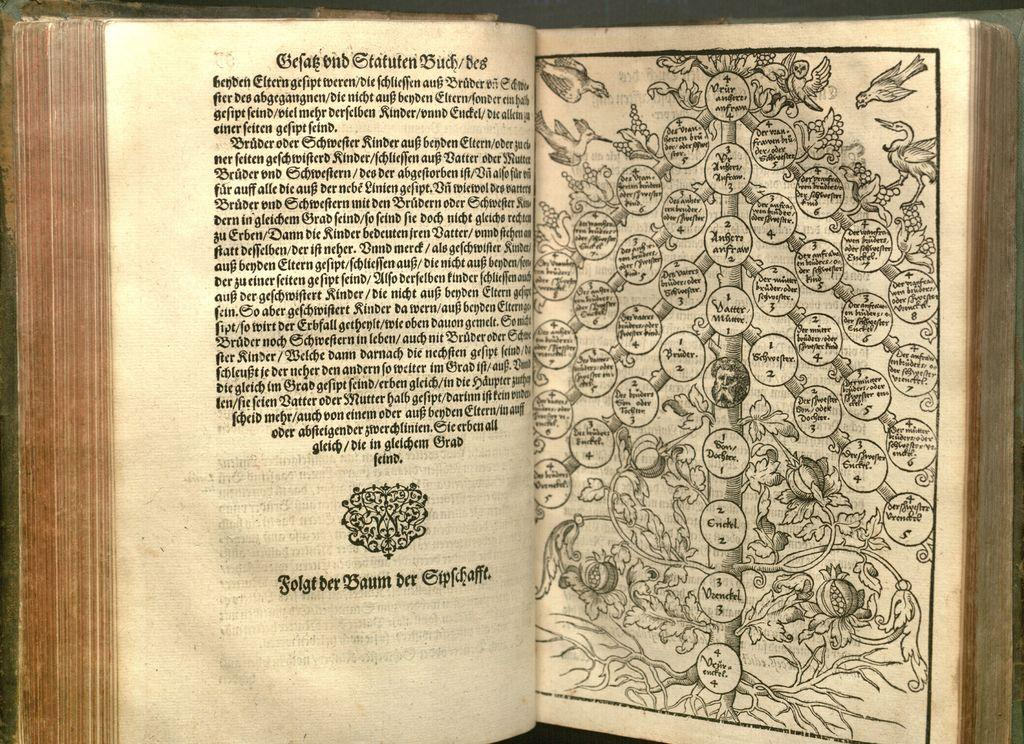<image>
Render a clear and concise summary of the photo. a book is open to a page of writing and a family tree with the name Bruder on one of the sections 